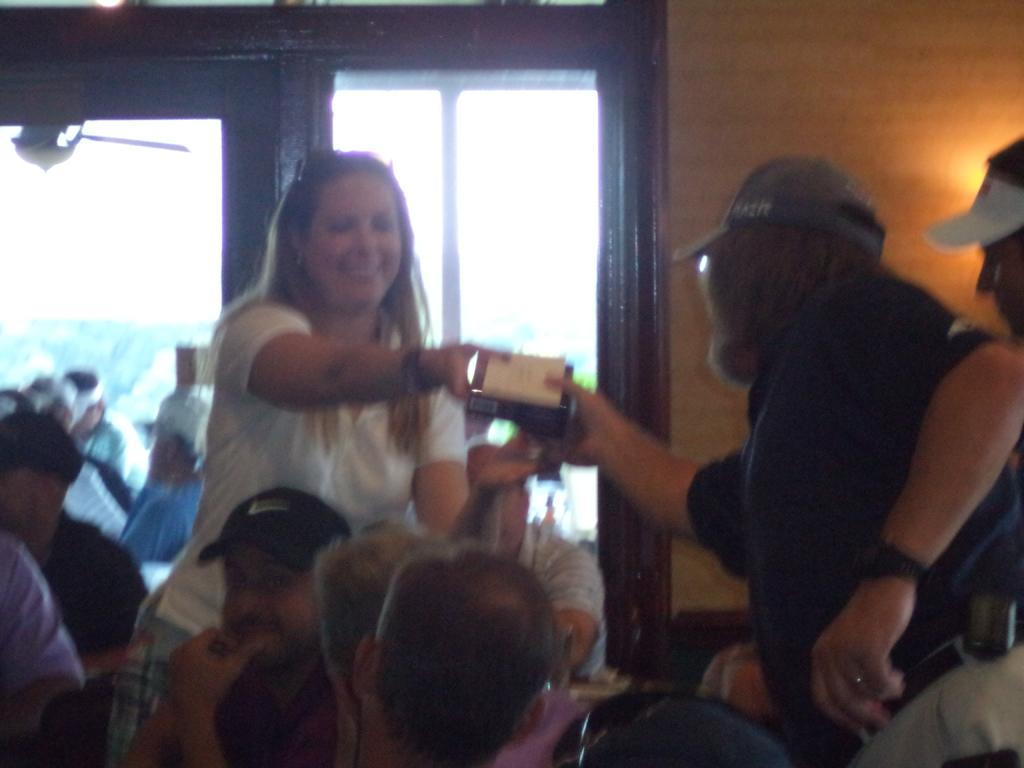How many people are in the image? There are people in the image, but the exact number is not specified. What are the people doing in the image? Some people are sitting, and some people are standing. What are the standing people holding? The standing people are holding objects. What can be seen in the background of the image? There is a window and a wall in the background of the image. What type of doll is sitting on the face of the person in the image? There is no doll or face present in the image; it only shows people sitting and standing, along with a window and a wall in the background. 